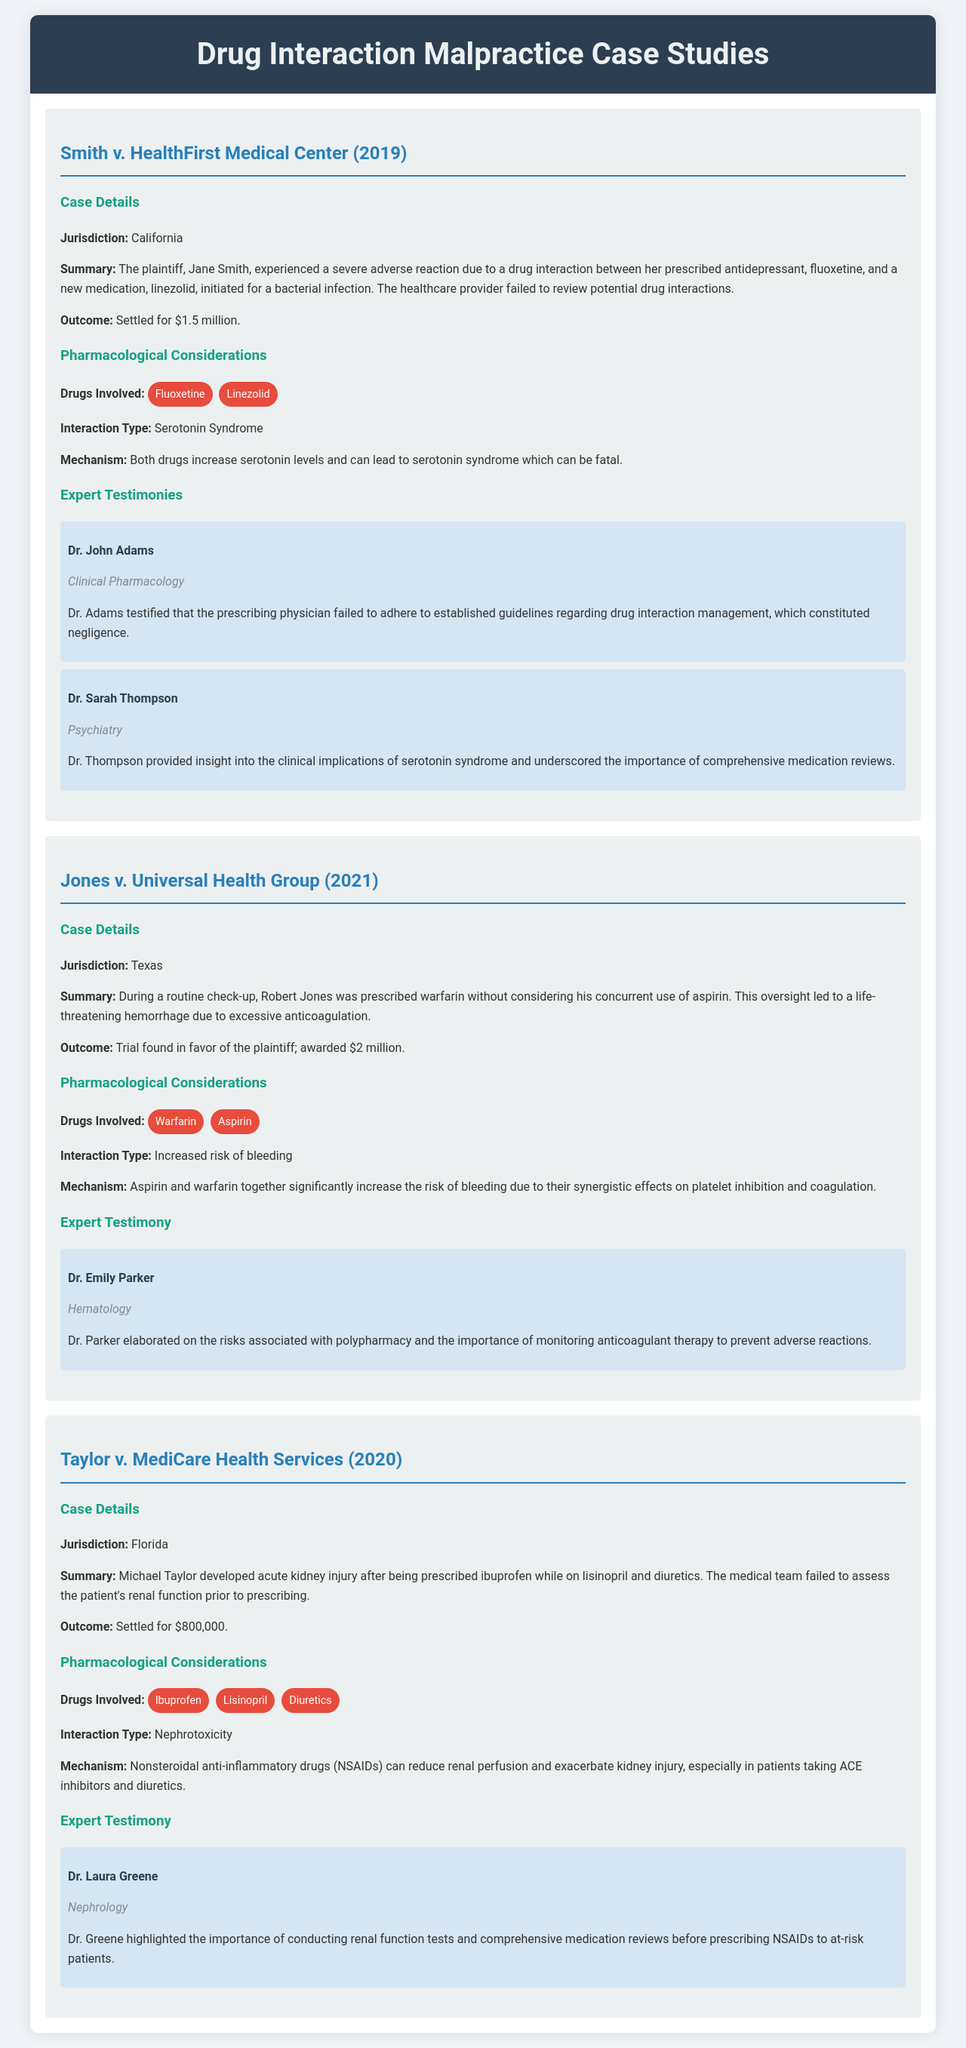What was the outcome of Smith v. HealthFirst Medical Center? The outcome of Smith v. HealthFirst Medical Center was settled for $1.5 million.
Answer: $1.5 million What drug interaction caused serotonin syndrome in the Smith case? The drug interaction that caused serotonin syndrome was between fluoxetine and linezolid.
Answer: fluoxetine and linezolid Who testified regarding the clinical implications of serotonin syndrome? Dr. Sarah Thompson provided insight into the clinical implications of serotonin syndrome.
Answer: Dr. Sarah Thompson What was Robert Jones prescribed during his check-up? Robert Jones was prescribed warfarin without considering his concurrent use of aspirin.
Answer: warfarin In the Taylor case, what medical condition developed after prescribing ibuprofen? Michael Taylor developed acute kidney injury after being prescribed ibuprofen.
Answer: acute kidney injury What type of interaction was involved in Jones v. Universal Health Group? The type of interaction involved in Jones v. Universal Health Group was an increased risk of bleeding.
Answer: increased risk of bleeding Which expert emphasized the importance of renal function tests? Dr. Laura Greene highlighted the importance of conducting renal function tests.
Answer: Dr. Laura Greene In what year was the Jones v. Universal Health Group trial decided? The Jones v. Universal Health Group trial was decided in 2021.
Answer: 2021 What drugs were involved in the nephrotoxicity interaction in the Taylor case? The drugs involved in the nephrotoxicity interaction were ibuprofen, lisinopril, and diuretics.
Answer: ibuprofen, lisinopril, and diuretics 